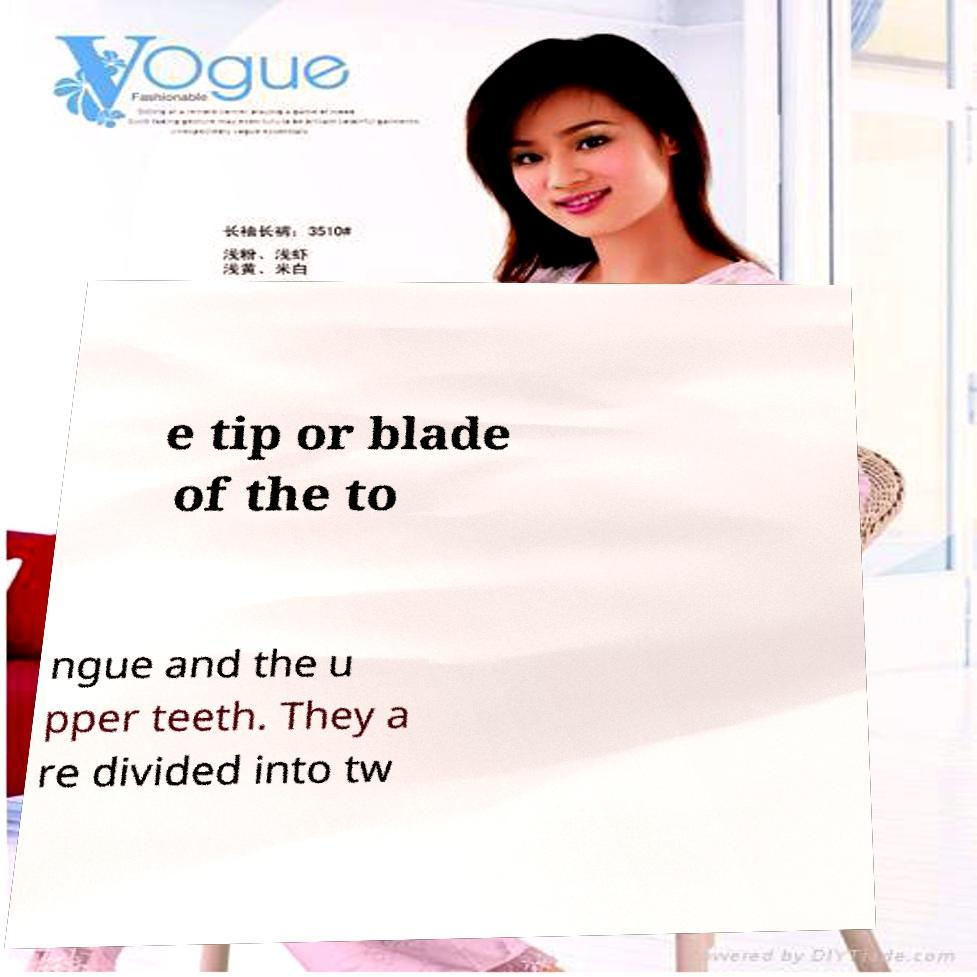Can you read and provide the text displayed in the image?This photo seems to have some interesting text. Can you extract and type it out for me? e tip or blade of the to ngue and the u pper teeth. They a re divided into tw 